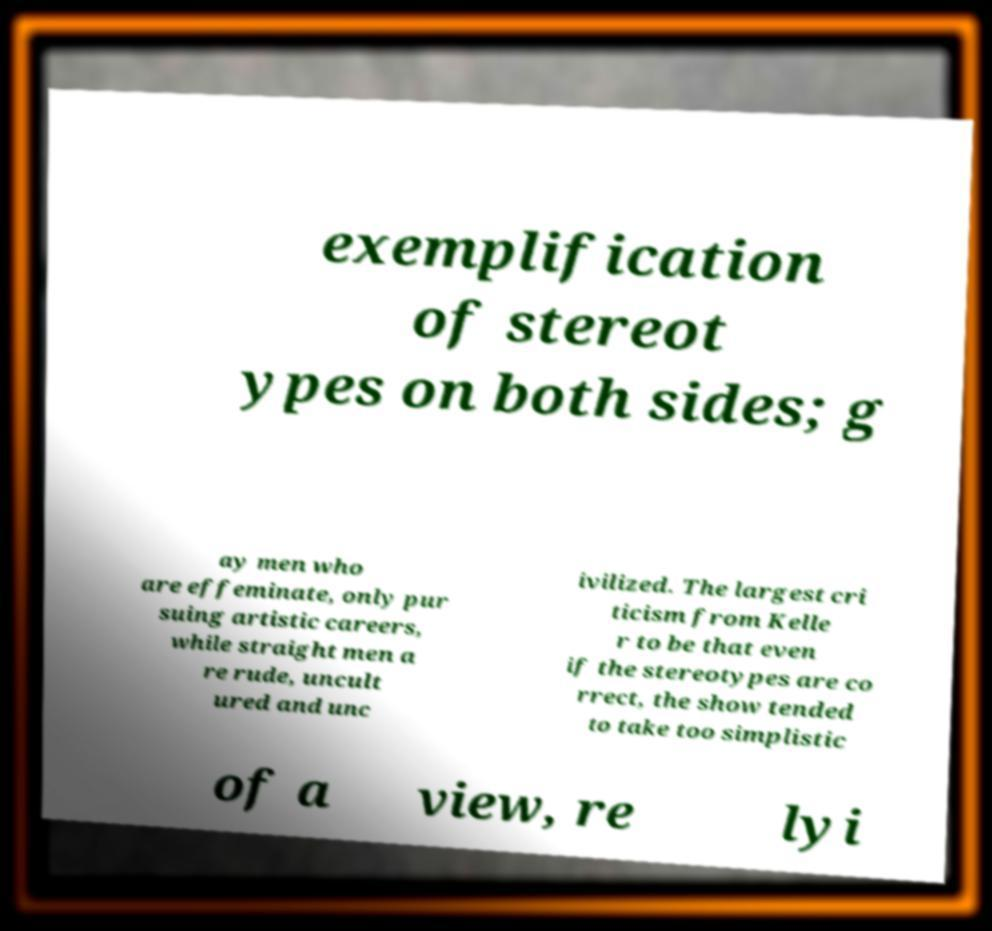What messages or text are displayed in this image? I need them in a readable, typed format. exemplification of stereot ypes on both sides; g ay men who are effeminate, only pur suing artistic careers, while straight men a re rude, uncult ured and unc ivilized. The largest cri ticism from Kelle r to be that even if the stereotypes are co rrect, the show tended to take too simplistic of a view, re lyi 